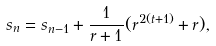Convert formula to latex. <formula><loc_0><loc_0><loc_500><loc_500>s _ { n } = s _ { n - 1 } + \frac { 1 } { r + 1 } ( r ^ { 2 ( t + 1 ) } + r ) ,</formula> 